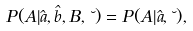<formula> <loc_0><loc_0><loc_500><loc_500>P ( A | \hat { a } , \hat { b } , B , \lambda ) = P ( A | \hat { a } , \lambda ) ,</formula> 